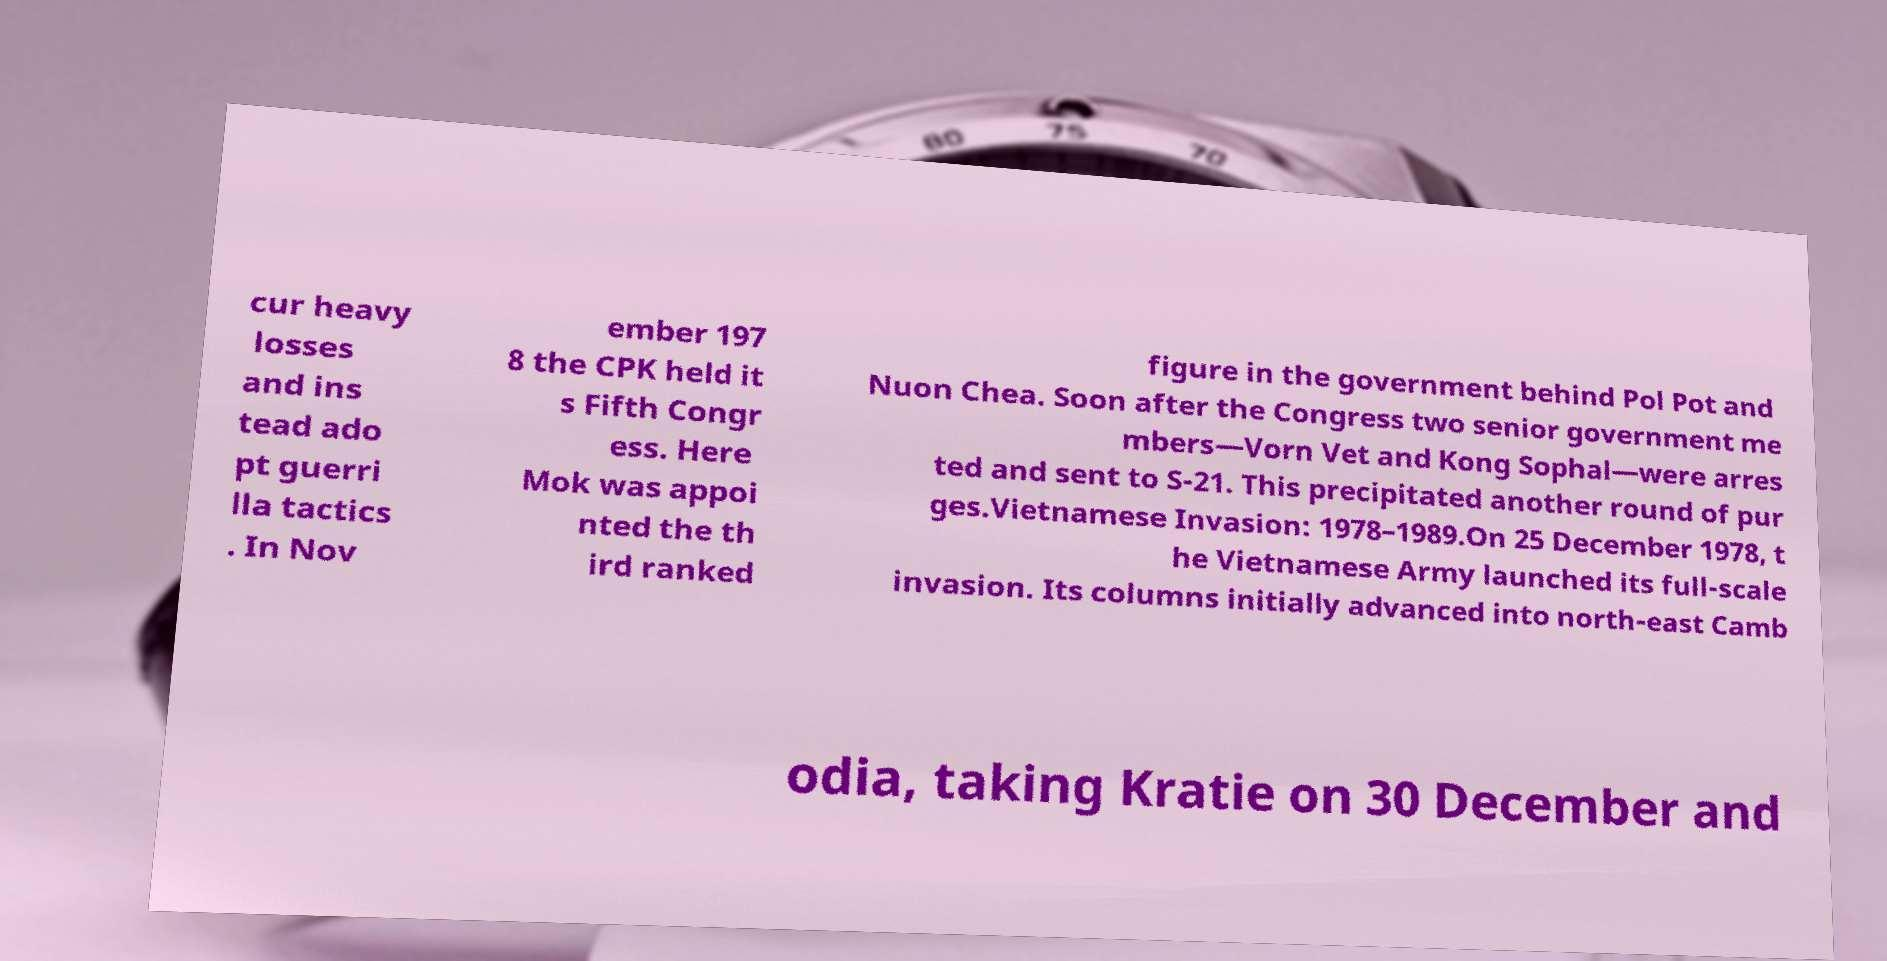Please identify and transcribe the text found in this image. cur heavy losses and ins tead ado pt guerri lla tactics . In Nov ember 197 8 the CPK held it s Fifth Congr ess. Here Mok was appoi nted the th ird ranked figure in the government behind Pol Pot and Nuon Chea. Soon after the Congress two senior government me mbers—Vorn Vet and Kong Sophal—were arres ted and sent to S-21. This precipitated another round of pur ges.Vietnamese Invasion: 1978–1989.On 25 December 1978, t he Vietnamese Army launched its full-scale invasion. Its columns initially advanced into north-east Camb odia, taking Kratie on 30 December and 